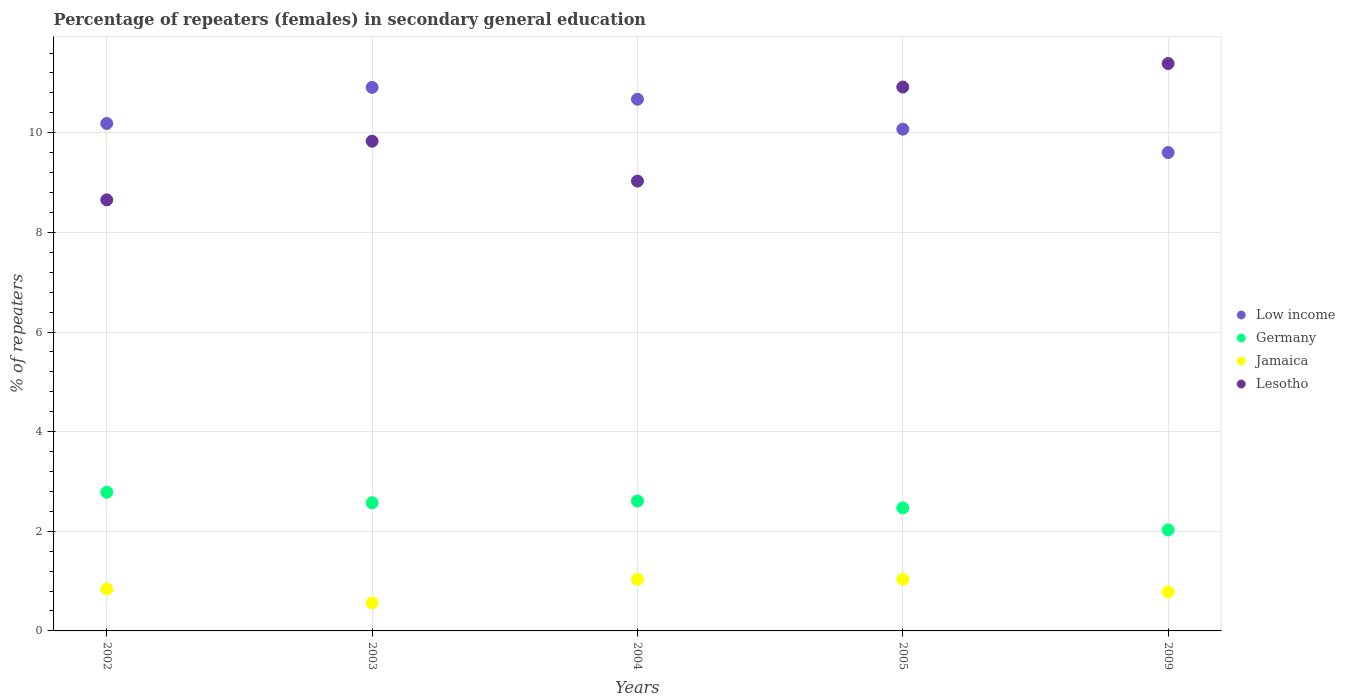What is the percentage of female repeaters in Lesotho in 2002?
Your answer should be compact. 8.65. Across all years, what is the maximum percentage of female repeaters in Germany?
Offer a terse response. 2.78. Across all years, what is the minimum percentage of female repeaters in Germany?
Your response must be concise. 2.03. In which year was the percentage of female repeaters in Lesotho minimum?
Your response must be concise. 2002. What is the total percentage of female repeaters in Germany in the graph?
Offer a terse response. 12.46. What is the difference between the percentage of female repeaters in Low income in 2003 and that in 2005?
Make the answer very short. 0.84. What is the difference between the percentage of female repeaters in Low income in 2003 and the percentage of female repeaters in Lesotho in 2009?
Keep it short and to the point. -0.48. What is the average percentage of female repeaters in Germany per year?
Your answer should be compact. 2.49. In the year 2004, what is the difference between the percentage of female repeaters in Germany and percentage of female repeaters in Low income?
Give a very brief answer. -8.06. What is the ratio of the percentage of female repeaters in Jamaica in 2002 to that in 2009?
Offer a very short reply. 1.07. Is the difference between the percentage of female repeaters in Germany in 2002 and 2003 greater than the difference between the percentage of female repeaters in Low income in 2002 and 2003?
Provide a short and direct response. Yes. What is the difference between the highest and the second highest percentage of female repeaters in Lesotho?
Your answer should be compact. 0.47. What is the difference between the highest and the lowest percentage of female repeaters in Jamaica?
Ensure brevity in your answer.  0.47. Is the sum of the percentage of female repeaters in Jamaica in 2002 and 2004 greater than the maximum percentage of female repeaters in Germany across all years?
Keep it short and to the point. No. Is it the case that in every year, the sum of the percentage of female repeaters in Jamaica and percentage of female repeaters in Germany  is greater than the percentage of female repeaters in Low income?
Offer a terse response. No. Is the percentage of female repeaters in Low income strictly greater than the percentage of female repeaters in Jamaica over the years?
Offer a very short reply. Yes. What is the difference between two consecutive major ticks on the Y-axis?
Keep it short and to the point. 2. Are the values on the major ticks of Y-axis written in scientific E-notation?
Provide a short and direct response. No. Does the graph contain any zero values?
Make the answer very short. No. How many legend labels are there?
Provide a short and direct response. 4. How are the legend labels stacked?
Give a very brief answer. Vertical. What is the title of the graph?
Make the answer very short. Percentage of repeaters (females) in secondary general education. Does "Libya" appear as one of the legend labels in the graph?
Your response must be concise. No. What is the label or title of the X-axis?
Your answer should be compact. Years. What is the label or title of the Y-axis?
Your response must be concise. % of repeaters. What is the % of repeaters in Low income in 2002?
Provide a short and direct response. 10.19. What is the % of repeaters of Germany in 2002?
Your answer should be compact. 2.78. What is the % of repeaters in Jamaica in 2002?
Make the answer very short. 0.84. What is the % of repeaters in Lesotho in 2002?
Ensure brevity in your answer.  8.65. What is the % of repeaters in Low income in 2003?
Provide a succinct answer. 10.91. What is the % of repeaters in Germany in 2003?
Offer a very short reply. 2.57. What is the % of repeaters in Jamaica in 2003?
Provide a succinct answer. 0.56. What is the % of repeaters of Lesotho in 2003?
Ensure brevity in your answer.  9.83. What is the % of repeaters of Low income in 2004?
Your response must be concise. 10.67. What is the % of repeaters of Germany in 2004?
Ensure brevity in your answer.  2.61. What is the % of repeaters of Jamaica in 2004?
Your response must be concise. 1.04. What is the % of repeaters in Lesotho in 2004?
Provide a short and direct response. 9.03. What is the % of repeaters in Low income in 2005?
Offer a very short reply. 10.07. What is the % of repeaters in Germany in 2005?
Provide a short and direct response. 2.47. What is the % of repeaters in Jamaica in 2005?
Provide a short and direct response. 1.04. What is the % of repeaters in Lesotho in 2005?
Make the answer very short. 10.92. What is the % of repeaters of Low income in 2009?
Make the answer very short. 9.6. What is the % of repeaters in Germany in 2009?
Provide a succinct answer. 2.03. What is the % of repeaters of Jamaica in 2009?
Your answer should be very brief. 0.78. What is the % of repeaters of Lesotho in 2009?
Make the answer very short. 11.39. Across all years, what is the maximum % of repeaters of Low income?
Ensure brevity in your answer.  10.91. Across all years, what is the maximum % of repeaters of Germany?
Keep it short and to the point. 2.78. Across all years, what is the maximum % of repeaters in Jamaica?
Provide a short and direct response. 1.04. Across all years, what is the maximum % of repeaters in Lesotho?
Your answer should be compact. 11.39. Across all years, what is the minimum % of repeaters of Low income?
Offer a terse response. 9.6. Across all years, what is the minimum % of repeaters of Germany?
Give a very brief answer. 2.03. Across all years, what is the minimum % of repeaters of Jamaica?
Ensure brevity in your answer.  0.56. Across all years, what is the minimum % of repeaters of Lesotho?
Offer a terse response. 8.65. What is the total % of repeaters of Low income in the graph?
Make the answer very short. 51.44. What is the total % of repeaters in Germany in the graph?
Offer a terse response. 12.46. What is the total % of repeaters of Jamaica in the graph?
Offer a very short reply. 4.26. What is the total % of repeaters of Lesotho in the graph?
Give a very brief answer. 49.82. What is the difference between the % of repeaters of Low income in 2002 and that in 2003?
Provide a succinct answer. -0.72. What is the difference between the % of repeaters of Germany in 2002 and that in 2003?
Provide a short and direct response. 0.21. What is the difference between the % of repeaters of Jamaica in 2002 and that in 2003?
Your answer should be compact. 0.28. What is the difference between the % of repeaters of Lesotho in 2002 and that in 2003?
Offer a terse response. -1.18. What is the difference between the % of repeaters in Low income in 2002 and that in 2004?
Offer a very short reply. -0.49. What is the difference between the % of repeaters in Germany in 2002 and that in 2004?
Ensure brevity in your answer.  0.18. What is the difference between the % of repeaters of Jamaica in 2002 and that in 2004?
Give a very brief answer. -0.19. What is the difference between the % of repeaters in Lesotho in 2002 and that in 2004?
Provide a succinct answer. -0.38. What is the difference between the % of repeaters of Low income in 2002 and that in 2005?
Provide a succinct answer. 0.11. What is the difference between the % of repeaters in Germany in 2002 and that in 2005?
Ensure brevity in your answer.  0.31. What is the difference between the % of repeaters in Jamaica in 2002 and that in 2005?
Your answer should be very brief. -0.19. What is the difference between the % of repeaters in Lesotho in 2002 and that in 2005?
Your response must be concise. -2.26. What is the difference between the % of repeaters of Low income in 2002 and that in 2009?
Provide a short and direct response. 0.58. What is the difference between the % of repeaters of Germany in 2002 and that in 2009?
Provide a short and direct response. 0.76. What is the difference between the % of repeaters of Jamaica in 2002 and that in 2009?
Provide a short and direct response. 0.06. What is the difference between the % of repeaters of Lesotho in 2002 and that in 2009?
Ensure brevity in your answer.  -2.74. What is the difference between the % of repeaters of Low income in 2003 and that in 2004?
Make the answer very short. 0.24. What is the difference between the % of repeaters of Germany in 2003 and that in 2004?
Offer a very short reply. -0.04. What is the difference between the % of repeaters in Jamaica in 2003 and that in 2004?
Your response must be concise. -0.47. What is the difference between the % of repeaters of Lesotho in 2003 and that in 2004?
Your response must be concise. 0.8. What is the difference between the % of repeaters of Low income in 2003 and that in 2005?
Give a very brief answer. 0.84. What is the difference between the % of repeaters of Germany in 2003 and that in 2005?
Ensure brevity in your answer.  0.1. What is the difference between the % of repeaters of Jamaica in 2003 and that in 2005?
Provide a short and direct response. -0.47. What is the difference between the % of repeaters in Lesotho in 2003 and that in 2005?
Your response must be concise. -1.09. What is the difference between the % of repeaters in Low income in 2003 and that in 2009?
Provide a succinct answer. 1.31. What is the difference between the % of repeaters in Germany in 2003 and that in 2009?
Ensure brevity in your answer.  0.55. What is the difference between the % of repeaters in Jamaica in 2003 and that in 2009?
Make the answer very short. -0.22. What is the difference between the % of repeaters in Lesotho in 2003 and that in 2009?
Make the answer very short. -1.56. What is the difference between the % of repeaters of Low income in 2004 and that in 2005?
Offer a terse response. 0.6. What is the difference between the % of repeaters of Germany in 2004 and that in 2005?
Ensure brevity in your answer.  0.14. What is the difference between the % of repeaters of Jamaica in 2004 and that in 2005?
Ensure brevity in your answer.  -0. What is the difference between the % of repeaters in Lesotho in 2004 and that in 2005?
Your response must be concise. -1.89. What is the difference between the % of repeaters in Low income in 2004 and that in 2009?
Offer a very short reply. 1.07. What is the difference between the % of repeaters in Germany in 2004 and that in 2009?
Provide a succinct answer. 0.58. What is the difference between the % of repeaters of Jamaica in 2004 and that in 2009?
Your answer should be very brief. 0.25. What is the difference between the % of repeaters of Lesotho in 2004 and that in 2009?
Your answer should be compact. -2.36. What is the difference between the % of repeaters of Low income in 2005 and that in 2009?
Make the answer very short. 0.47. What is the difference between the % of repeaters in Germany in 2005 and that in 2009?
Offer a very short reply. 0.44. What is the difference between the % of repeaters in Jamaica in 2005 and that in 2009?
Provide a succinct answer. 0.25. What is the difference between the % of repeaters of Lesotho in 2005 and that in 2009?
Give a very brief answer. -0.47. What is the difference between the % of repeaters of Low income in 2002 and the % of repeaters of Germany in 2003?
Your answer should be very brief. 7.61. What is the difference between the % of repeaters of Low income in 2002 and the % of repeaters of Jamaica in 2003?
Give a very brief answer. 9.62. What is the difference between the % of repeaters in Low income in 2002 and the % of repeaters in Lesotho in 2003?
Provide a short and direct response. 0.36. What is the difference between the % of repeaters in Germany in 2002 and the % of repeaters in Jamaica in 2003?
Your response must be concise. 2.22. What is the difference between the % of repeaters of Germany in 2002 and the % of repeaters of Lesotho in 2003?
Your answer should be compact. -7.05. What is the difference between the % of repeaters in Jamaica in 2002 and the % of repeaters in Lesotho in 2003?
Keep it short and to the point. -8.99. What is the difference between the % of repeaters of Low income in 2002 and the % of repeaters of Germany in 2004?
Provide a short and direct response. 7.58. What is the difference between the % of repeaters of Low income in 2002 and the % of repeaters of Jamaica in 2004?
Offer a very short reply. 9.15. What is the difference between the % of repeaters in Low income in 2002 and the % of repeaters in Lesotho in 2004?
Make the answer very short. 1.16. What is the difference between the % of repeaters in Germany in 2002 and the % of repeaters in Jamaica in 2004?
Your answer should be compact. 1.75. What is the difference between the % of repeaters in Germany in 2002 and the % of repeaters in Lesotho in 2004?
Provide a succinct answer. -6.25. What is the difference between the % of repeaters of Jamaica in 2002 and the % of repeaters of Lesotho in 2004?
Provide a short and direct response. -8.19. What is the difference between the % of repeaters of Low income in 2002 and the % of repeaters of Germany in 2005?
Your answer should be very brief. 7.72. What is the difference between the % of repeaters in Low income in 2002 and the % of repeaters in Jamaica in 2005?
Provide a short and direct response. 9.15. What is the difference between the % of repeaters in Low income in 2002 and the % of repeaters in Lesotho in 2005?
Your answer should be very brief. -0.73. What is the difference between the % of repeaters in Germany in 2002 and the % of repeaters in Jamaica in 2005?
Keep it short and to the point. 1.75. What is the difference between the % of repeaters in Germany in 2002 and the % of repeaters in Lesotho in 2005?
Keep it short and to the point. -8.13. What is the difference between the % of repeaters of Jamaica in 2002 and the % of repeaters of Lesotho in 2005?
Provide a short and direct response. -10.07. What is the difference between the % of repeaters in Low income in 2002 and the % of repeaters in Germany in 2009?
Your answer should be compact. 8.16. What is the difference between the % of repeaters of Low income in 2002 and the % of repeaters of Jamaica in 2009?
Your answer should be compact. 9.4. What is the difference between the % of repeaters of Low income in 2002 and the % of repeaters of Lesotho in 2009?
Keep it short and to the point. -1.2. What is the difference between the % of repeaters in Germany in 2002 and the % of repeaters in Jamaica in 2009?
Offer a very short reply. 2. What is the difference between the % of repeaters in Germany in 2002 and the % of repeaters in Lesotho in 2009?
Keep it short and to the point. -8.61. What is the difference between the % of repeaters in Jamaica in 2002 and the % of repeaters in Lesotho in 2009?
Provide a succinct answer. -10.55. What is the difference between the % of repeaters of Low income in 2003 and the % of repeaters of Germany in 2004?
Your response must be concise. 8.3. What is the difference between the % of repeaters in Low income in 2003 and the % of repeaters in Jamaica in 2004?
Give a very brief answer. 9.87. What is the difference between the % of repeaters of Low income in 2003 and the % of repeaters of Lesotho in 2004?
Keep it short and to the point. 1.88. What is the difference between the % of repeaters in Germany in 2003 and the % of repeaters in Jamaica in 2004?
Make the answer very short. 1.54. What is the difference between the % of repeaters in Germany in 2003 and the % of repeaters in Lesotho in 2004?
Offer a very short reply. -6.46. What is the difference between the % of repeaters in Jamaica in 2003 and the % of repeaters in Lesotho in 2004?
Offer a very short reply. -8.47. What is the difference between the % of repeaters of Low income in 2003 and the % of repeaters of Germany in 2005?
Keep it short and to the point. 8.44. What is the difference between the % of repeaters of Low income in 2003 and the % of repeaters of Jamaica in 2005?
Keep it short and to the point. 9.87. What is the difference between the % of repeaters of Low income in 2003 and the % of repeaters of Lesotho in 2005?
Make the answer very short. -0.01. What is the difference between the % of repeaters of Germany in 2003 and the % of repeaters of Jamaica in 2005?
Offer a terse response. 1.54. What is the difference between the % of repeaters of Germany in 2003 and the % of repeaters of Lesotho in 2005?
Ensure brevity in your answer.  -8.34. What is the difference between the % of repeaters in Jamaica in 2003 and the % of repeaters in Lesotho in 2005?
Your response must be concise. -10.35. What is the difference between the % of repeaters in Low income in 2003 and the % of repeaters in Germany in 2009?
Keep it short and to the point. 8.88. What is the difference between the % of repeaters in Low income in 2003 and the % of repeaters in Jamaica in 2009?
Ensure brevity in your answer.  10.13. What is the difference between the % of repeaters of Low income in 2003 and the % of repeaters of Lesotho in 2009?
Ensure brevity in your answer.  -0.48. What is the difference between the % of repeaters of Germany in 2003 and the % of repeaters of Jamaica in 2009?
Offer a terse response. 1.79. What is the difference between the % of repeaters of Germany in 2003 and the % of repeaters of Lesotho in 2009?
Your answer should be very brief. -8.82. What is the difference between the % of repeaters of Jamaica in 2003 and the % of repeaters of Lesotho in 2009?
Give a very brief answer. -10.83. What is the difference between the % of repeaters in Low income in 2004 and the % of repeaters in Germany in 2005?
Keep it short and to the point. 8.2. What is the difference between the % of repeaters of Low income in 2004 and the % of repeaters of Jamaica in 2005?
Provide a succinct answer. 9.64. What is the difference between the % of repeaters of Low income in 2004 and the % of repeaters of Lesotho in 2005?
Keep it short and to the point. -0.25. What is the difference between the % of repeaters in Germany in 2004 and the % of repeaters in Jamaica in 2005?
Your response must be concise. 1.57. What is the difference between the % of repeaters in Germany in 2004 and the % of repeaters in Lesotho in 2005?
Offer a terse response. -8.31. What is the difference between the % of repeaters of Jamaica in 2004 and the % of repeaters of Lesotho in 2005?
Make the answer very short. -9.88. What is the difference between the % of repeaters in Low income in 2004 and the % of repeaters in Germany in 2009?
Provide a short and direct response. 8.64. What is the difference between the % of repeaters in Low income in 2004 and the % of repeaters in Jamaica in 2009?
Provide a succinct answer. 9.89. What is the difference between the % of repeaters in Low income in 2004 and the % of repeaters in Lesotho in 2009?
Offer a terse response. -0.72. What is the difference between the % of repeaters of Germany in 2004 and the % of repeaters of Jamaica in 2009?
Offer a terse response. 1.82. What is the difference between the % of repeaters of Germany in 2004 and the % of repeaters of Lesotho in 2009?
Keep it short and to the point. -8.78. What is the difference between the % of repeaters of Jamaica in 2004 and the % of repeaters of Lesotho in 2009?
Give a very brief answer. -10.35. What is the difference between the % of repeaters of Low income in 2005 and the % of repeaters of Germany in 2009?
Provide a short and direct response. 8.04. What is the difference between the % of repeaters of Low income in 2005 and the % of repeaters of Jamaica in 2009?
Ensure brevity in your answer.  9.29. What is the difference between the % of repeaters of Low income in 2005 and the % of repeaters of Lesotho in 2009?
Provide a short and direct response. -1.32. What is the difference between the % of repeaters of Germany in 2005 and the % of repeaters of Jamaica in 2009?
Keep it short and to the point. 1.69. What is the difference between the % of repeaters in Germany in 2005 and the % of repeaters in Lesotho in 2009?
Provide a succinct answer. -8.92. What is the difference between the % of repeaters of Jamaica in 2005 and the % of repeaters of Lesotho in 2009?
Your response must be concise. -10.35. What is the average % of repeaters in Low income per year?
Your answer should be very brief. 10.29. What is the average % of repeaters of Germany per year?
Provide a short and direct response. 2.49. What is the average % of repeaters of Jamaica per year?
Keep it short and to the point. 0.85. What is the average % of repeaters in Lesotho per year?
Provide a succinct answer. 9.96. In the year 2002, what is the difference between the % of repeaters of Low income and % of repeaters of Germany?
Provide a succinct answer. 7.4. In the year 2002, what is the difference between the % of repeaters of Low income and % of repeaters of Jamaica?
Offer a terse response. 9.34. In the year 2002, what is the difference between the % of repeaters of Low income and % of repeaters of Lesotho?
Your response must be concise. 1.53. In the year 2002, what is the difference between the % of repeaters of Germany and % of repeaters of Jamaica?
Your answer should be compact. 1.94. In the year 2002, what is the difference between the % of repeaters of Germany and % of repeaters of Lesotho?
Your answer should be compact. -5.87. In the year 2002, what is the difference between the % of repeaters of Jamaica and % of repeaters of Lesotho?
Your answer should be compact. -7.81. In the year 2003, what is the difference between the % of repeaters in Low income and % of repeaters in Germany?
Offer a terse response. 8.34. In the year 2003, what is the difference between the % of repeaters in Low income and % of repeaters in Jamaica?
Provide a short and direct response. 10.35. In the year 2003, what is the difference between the % of repeaters in Low income and % of repeaters in Lesotho?
Provide a short and direct response. 1.08. In the year 2003, what is the difference between the % of repeaters in Germany and % of repeaters in Jamaica?
Provide a succinct answer. 2.01. In the year 2003, what is the difference between the % of repeaters in Germany and % of repeaters in Lesotho?
Ensure brevity in your answer.  -7.26. In the year 2003, what is the difference between the % of repeaters in Jamaica and % of repeaters in Lesotho?
Provide a short and direct response. -9.27. In the year 2004, what is the difference between the % of repeaters in Low income and % of repeaters in Germany?
Ensure brevity in your answer.  8.06. In the year 2004, what is the difference between the % of repeaters in Low income and % of repeaters in Jamaica?
Your response must be concise. 9.64. In the year 2004, what is the difference between the % of repeaters of Low income and % of repeaters of Lesotho?
Your answer should be compact. 1.64. In the year 2004, what is the difference between the % of repeaters in Germany and % of repeaters in Jamaica?
Provide a short and direct response. 1.57. In the year 2004, what is the difference between the % of repeaters in Germany and % of repeaters in Lesotho?
Provide a short and direct response. -6.42. In the year 2004, what is the difference between the % of repeaters of Jamaica and % of repeaters of Lesotho?
Make the answer very short. -7.99. In the year 2005, what is the difference between the % of repeaters of Low income and % of repeaters of Germany?
Your answer should be very brief. 7.6. In the year 2005, what is the difference between the % of repeaters of Low income and % of repeaters of Jamaica?
Keep it short and to the point. 9.03. In the year 2005, what is the difference between the % of repeaters in Low income and % of repeaters in Lesotho?
Provide a short and direct response. -0.85. In the year 2005, what is the difference between the % of repeaters of Germany and % of repeaters of Jamaica?
Ensure brevity in your answer.  1.43. In the year 2005, what is the difference between the % of repeaters in Germany and % of repeaters in Lesotho?
Your answer should be compact. -8.45. In the year 2005, what is the difference between the % of repeaters in Jamaica and % of repeaters in Lesotho?
Offer a terse response. -9.88. In the year 2009, what is the difference between the % of repeaters in Low income and % of repeaters in Germany?
Your answer should be very brief. 7.57. In the year 2009, what is the difference between the % of repeaters in Low income and % of repeaters in Jamaica?
Keep it short and to the point. 8.82. In the year 2009, what is the difference between the % of repeaters of Low income and % of repeaters of Lesotho?
Keep it short and to the point. -1.79. In the year 2009, what is the difference between the % of repeaters of Germany and % of repeaters of Jamaica?
Your answer should be compact. 1.24. In the year 2009, what is the difference between the % of repeaters in Germany and % of repeaters in Lesotho?
Ensure brevity in your answer.  -9.36. In the year 2009, what is the difference between the % of repeaters of Jamaica and % of repeaters of Lesotho?
Keep it short and to the point. -10.6. What is the ratio of the % of repeaters of Low income in 2002 to that in 2003?
Your response must be concise. 0.93. What is the ratio of the % of repeaters of Germany in 2002 to that in 2003?
Provide a short and direct response. 1.08. What is the ratio of the % of repeaters in Jamaica in 2002 to that in 2003?
Ensure brevity in your answer.  1.5. What is the ratio of the % of repeaters in Lesotho in 2002 to that in 2003?
Provide a succinct answer. 0.88. What is the ratio of the % of repeaters in Low income in 2002 to that in 2004?
Give a very brief answer. 0.95. What is the ratio of the % of repeaters in Germany in 2002 to that in 2004?
Your response must be concise. 1.07. What is the ratio of the % of repeaters in Jamaica in 2002 to that in 2004?
Your answer should be very brief. 0.81. What is the ratio of the % of repeaters in Lesotho in 2002 to that in 2004?
Your response must be concise. 0.96. What is the ratio of the % of repeaters of Low income in 2002 to that in 2005?
Make the answer very short. 1.01. What is the ratio of the % of repeaters of Germany in 2002 to that in 2005?
Provide a succinct answer. 1.13. What is the ratio of the % of repeaters of Jamaica in 2002 to that in 2005?
Ensure brevity in your answer.  0.81. What is the ratio of the % of repeaters of Lesotho in 2002 to that in 2005?
Provide a succinct answer. 0.79. What is the ratio of the % of repeaters in Low income in 2002 to that in 2009?
Your answer should be compact. 1.06. What is the ratio of the % of repeaters in Germany in 2002 to that in 2009?
Offer a very short reply. 1.37. What is the ratio of the % of repeaters in Jamaica in 2002 to that in 2009?
Provide a succinct answer. 1.07. What is the ratio of the % of repeaters of Lesotho in 2002 to that in 2009?
Make the answer very short. 0.76. What is the ratio of the % of repeaters of Low income in 2003 to that in 2004?
Your response must be concise. 1.02. What is the ratio of the % of repeaters of Germany in 2003 to that in 2004?
Your answer should be very brief. 0.99. What is the ratio of the % of repeaters in Jamaica in 2003 to that in 2004?
Provide a succinct answer. 0.54. What is the ratio of the % of repeaters in Lesotho in 2003 to that in 2004?
Your answer should be very brief. 1.09. What is the ratio of the % of repeaters in Low income in 2003 to that in 2005?
Give a very brief answer. 1.08. What is the ratio of the % of repeaters of Germany in 2003 to that in 2005?
Ensure brevity in your answer.  1.04. What is the ratio of the % of repeaters of Jamaica in 2003 to that in 2005?
Provide a short and direct response. 0.54. What is the ratio of the % of repeaters of Lesotho in 2003 to that in 2005?
Provide a succinct answer. 0.9. What is the ratio of the % of repeaters of Low income in 2003 to that in 2009?
Provide a short and direct response. 1.14. What is the ratio of the % of repeaters in Germany in 2003 to that in 2009?
Offer a very short reply. 1.27. What is the ratio of the % of repeaters of Jamaica in 2003 to that in 2009?
Offer a very short reply. 0.72. What is the ratio of the % of repeaters of Lesotho in 2003 to that in 2009?
Your answer should be very brief. 0.86. What is the ratio of the % of repeaters of Low income in 2004 to that in 2005?
Provide a succinct answer. 1.06. What is the ratio of the % of repeaters of Germany in 2004 to that in 2005?
Provide a succinct answer. 1.06. What is the ratio of the % of repeaters of Jamaica in 2004 to that in 2005?
Your answer should be compact. 1. What is the ratio of the % of repeaters in Lesotho in 2004 to that in 2005?
Your answer should be very brief. 0.83. What is the ratio of the % of repeaters of Low income in 2004 to that in 2009?
Offer a very short reply. 1.11. What is the ratio of the % of repeaters in Germany in 2004 to that in 2009?
Ensure brevity in your answer.  1.29. What is the ratio of the % of repeaters in Jamaica in 2004 to that in 2009?
Give a very brief answer. 1.32. What is the ratio of the % of repeaters in Lesotho in 2004 to that in 2009?
Provide a succinct answer. 0.79. What is the ratio of the % of repeaters in Low income in 2005 to that in 2009?
Give a very brief answer. 1.05. What is the ratio of the % of repeaters of Germany in 2005 to that in 2009?
Your response must be concise. 1.22. What is the ratio of the % of repeaters of Jamaica in 2005 to that in 2009?
Give a very brief answer. 1.32. What is the ratio of the % of repeaters of Lesotho in 2005 to that in 2009?
Give a very brief answer. 0.96. What is the difference between the highest and the second highest % of repeaters in Low income?
Provide a short and direct response. 0.24. What is the difference between the highest and the second highest % of repeaters of Germany?
Ensure brevity in your answer.  0.18. What is the difference between the highest and the second highest % of repeaters in Jamaica?
Offer a very short reply. 0. What is the difference between the highest and the second highest % of repeaters of Lesotho?
Offer a very short reply. 0.47. What is the difference between the highest and the lowest % of repeaters of Low income?
Your answer should be very brief. 1.31. What is the difference between the highest and the lowest % of repeaters in Germany?
Give a very brief answer. 0.76. What is the difference between the highest and the lowest % of repeaters in Jamaica?
Give a very brief answer. 0.47. What is the difference between the highest and the lowest % of repeaters of Lesotho?
Ensure brevity in your answer.  2.74. 